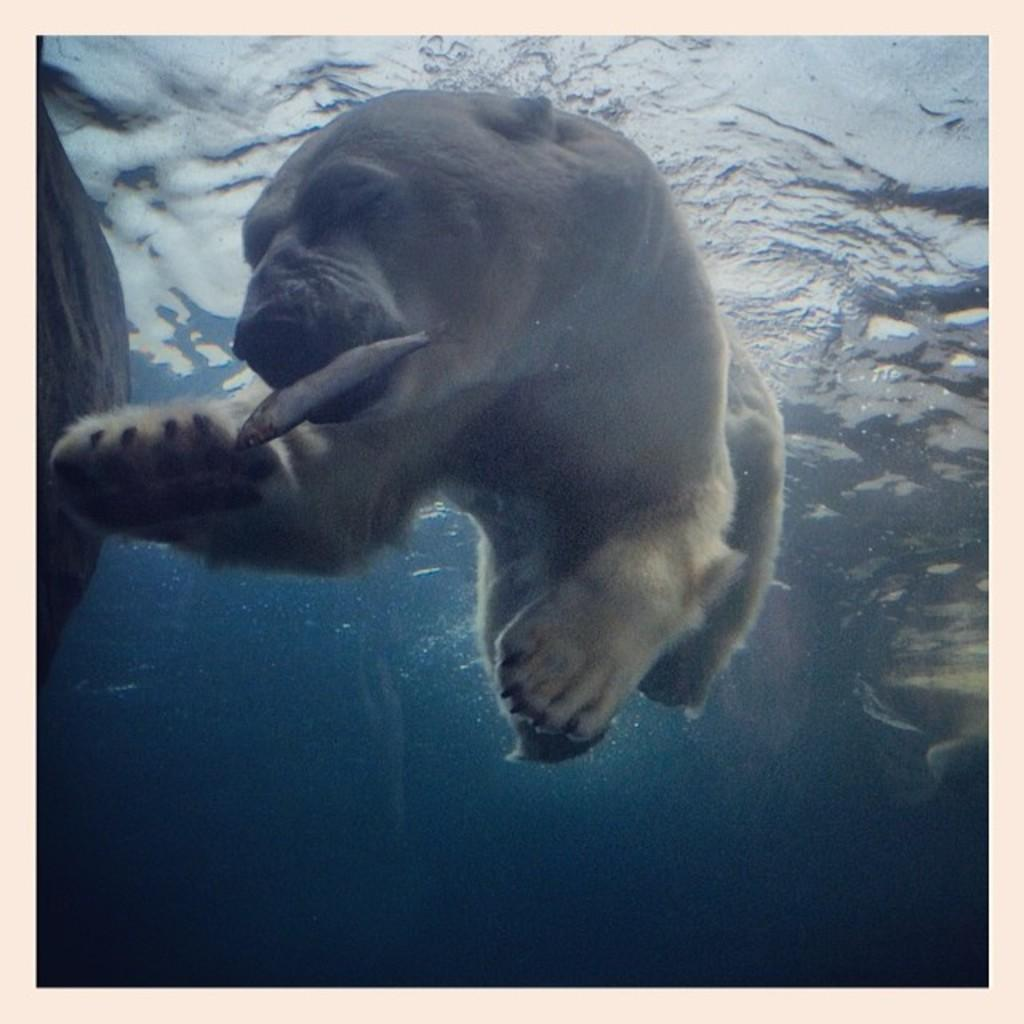What is the main subject of the picture? The main subject of the picture is a white bear in the water. What is the white bear doing in the water? The white bear is holding a fish in its mouth. What else can be seen in the picture besides the white bear? There is water visible in the picture. What type of wine is the white bear drinking in the picture? There is no wine present in the image; the white bear is holding a fish in its mouth. What is the white bear using to hold the fish in the picture? The white bear is using its mouth to hold the fish in the picture. 